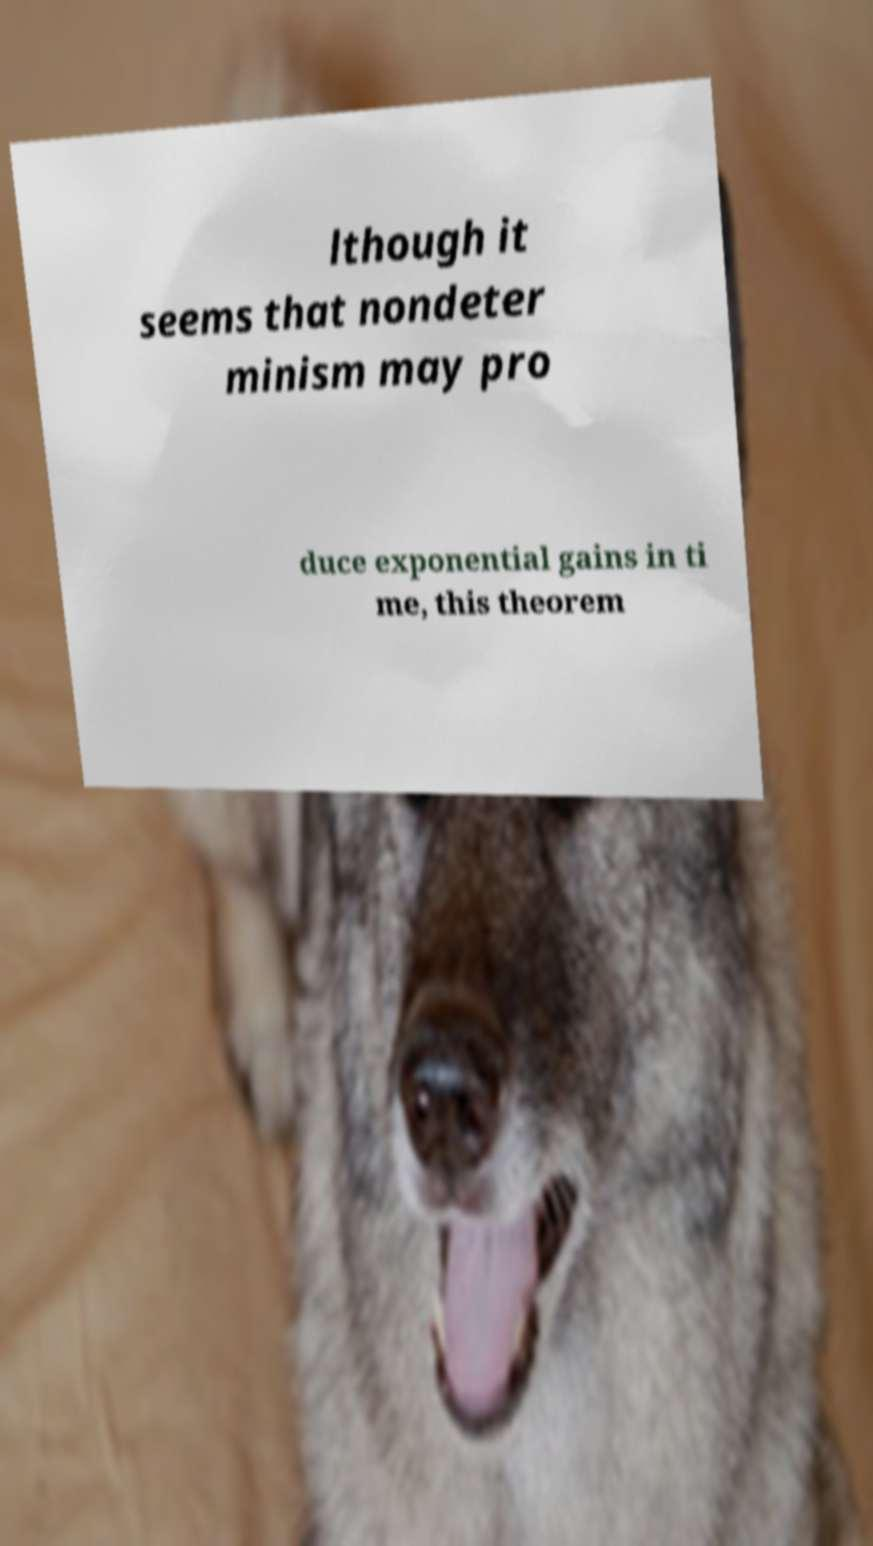Please read and relay the text visible in this image. What does it say? lthough it seems that nondeter minism may pro duce exponential gains in ti me, this theorem 